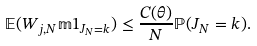Convert formula to latex. <formula><loc_0><loc_0><loc_500><loc_500>\mathbb { E } ( W _ { j , N } \mathbb { m } { 1 } _ { J _ { N } = k } ) \leq \frac { C ( \theta ) } { N } \mathbb { P } ( J _ { N } = k ) .</formula> 